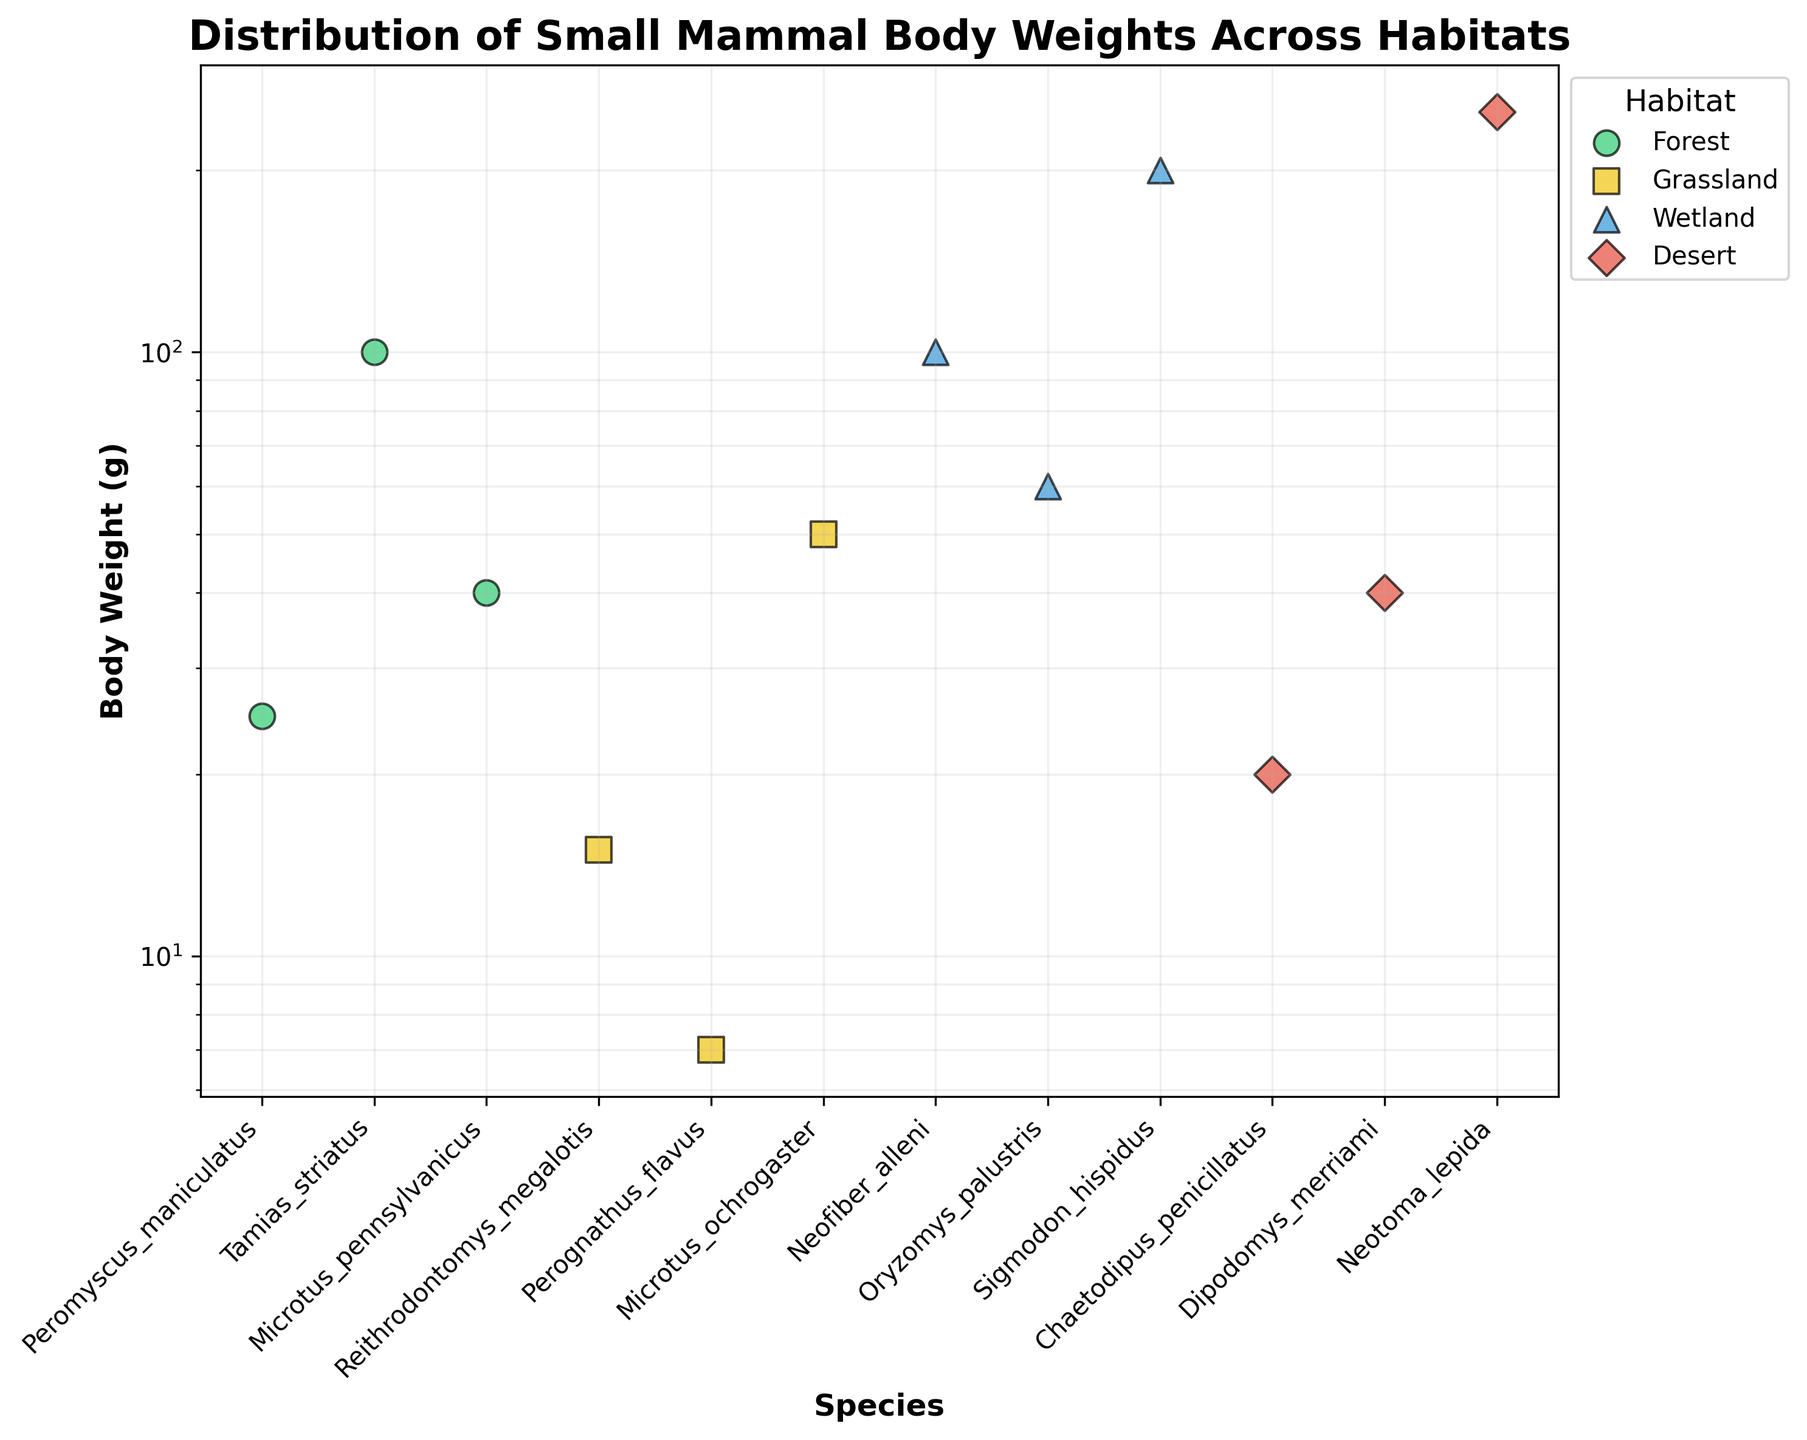What is the title of the scatter plot? The title is written at the top of the scatter plot in bold font. It reads "Distribution of Small Mammal Body Weights Across Habitats."
Answer: Distribution of Small Mammal Body Weights Across Habitats What are the four different habitat types represented in the scatter plot? The habitats are indicated by different colors and are labeled in the legend on the right. The habitats are Forest, Grassland, Wetland, and Desert.
Answer: Forest, Grassland, Wetland, Desert Which species has the highest body weight, and what is that weight? By observing the y-axis (which is on a log scale) and looking for the highest data point, we see that Neotoma_lepida from the Desert habitat has the highest body weight of 250 grams.
Answer: Neotoma_lepida; 250 grams Which habitat has the widest range of body weights? Range is determined by the difference between the maximum and minimum body weights in each habitat.
    - Forest: 100 - 25 = 75 grams
    - Grassland: 50 - 7 = 43 grams
    - Wetland: 200 - 60 = 140 grams
    - Desert: 250 - 20 = 230 grams
    The Desert habitat has the widest range of body weights: 230 grams.
Answer: Desert Are there more species in the Forest habitat or the Grassland habitat? Count the number of data points in each habitat.
    - Forest: 3 species
    - Grassland: 3 species
    The count is equal for both habitats.
Answer: Equal; both have 3 species Which species in the Wetland habitat has the lowest body weight? By examining the data points within the Wetland habitat and identifying the one positioned lowest on the y-axis, Oryzomys_palustris with 60 grams is the species with the lowest body weight in the Wetland habitat.
Answer: Oryzomys_palustris; 60 grams How does the body weight of Microtus_ochrogaster in the Grassland habitat compare to that of Microtus_pennsylvanicus in the Forest habitat? Observe the data points for these species.
    - Microtus_ochrogaster (Grassland): 50 grams
    - Microtus_pennsylvanicus (Forest): 40 grams
    Microtus_ochrogaster is heavier by 10 grams.
Answer: Microtus_ochrogaster is 10 grams heavier 